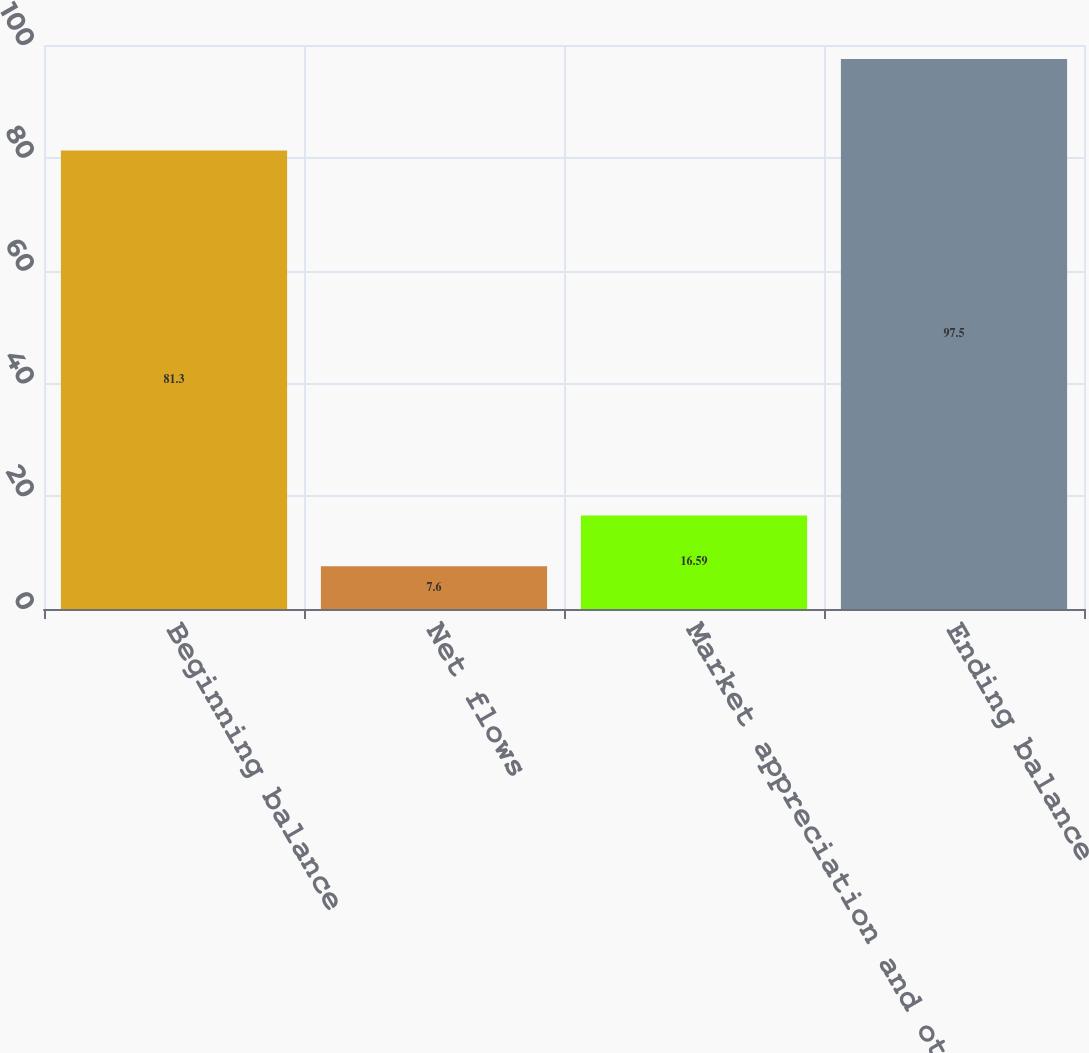Convert chart. <chart><loc_0><loc_0><loc_500><loc_500><bar_chart><fcel>Beginning balance<fcel>Net flows<fcel>Market appreciation and other<fcel>Ending balance<nl><fcel>81.3<fcel>7.6<fcel>16.59<fcel>97.5<nl></chart> 